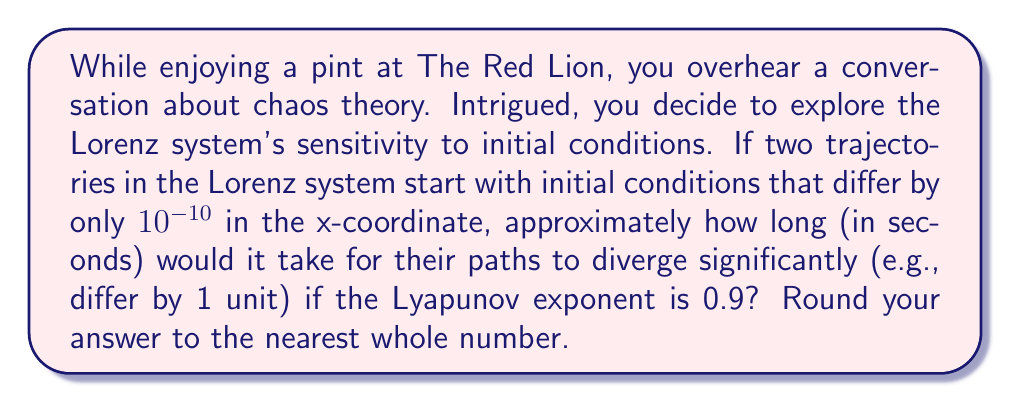Give your solution to this math problem. Let's approach this step-by-step:

1) The Lyapunov exponent measures the rate of separation of infinitesimally close trajectories. In this case, it's given as 0.9.

2) The general formula for the divergence of trajectories is:

   $$d(t) = d_0 e^{\lambda t}$$

   Where:
   $d(t)$ is the distance between trajectories at time $t$
   $d_0$ is the initial separation
   $\lambda$ is the Lyapunov exponent
   $t$ is time

3) We're given:
   $d_0 = 10^{-10}$ (initial difference)
   $\lambda = 0.9$ (Lyapunov exponent)
   $d(t) = 1$ (we want to know when the difference becomes 1 unit)

4) Plugging these into the equation:

   $$1 = 10^{-10} e^{0.9t}$$

5) Solving for $t$:

   $$e^{0.9t} = 10^{10}$$

   $$0.9t = \ln(10^{10})$$

   $$0.9t = 10 \ln(10)$$

   $$t = \frac{10 \ln(10)}{0.9}$$

6) Calculate:

   $$t = \frac{10 * 2.30258509}{0.9} \approx 25.58 \text{ seconds}$$

7) Rounding to the nearest whole number:

   $t \approx 26 \text{ seconds}$
Answer: 26 seconds 